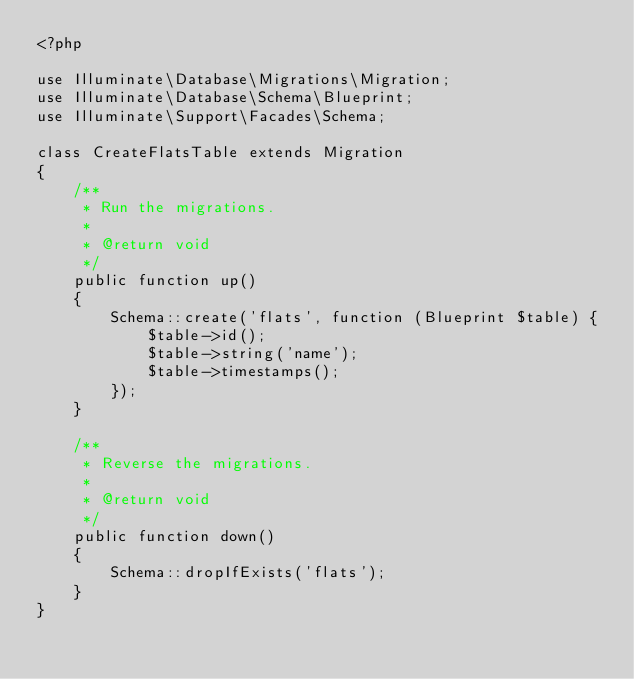Convert code to text. <code><loc_0><loc_0><loc_500><loc_500><_PHP_><?php

use Illuminate\Database\Migrations\Migration;
use Illuminate\Database\Schema\Blueprint;
use Illuminate\Support\Facades\Schema;

class CreateFlatsTable extends Migration
{
    /**
     * Run the migrations.
     *
     * @return void
     */
    public function up()
    {
        Schema::create('flats', function (Blueprint $table) {
            $table->id();
            $table->string('name');
            $table->timestamps();
        });
    }

    /**
     * Reverse the migrations.
     *
     * @return void
     */
    public function down()
    {
        Schema::dropIfExists('flats');
    }
}
</code> 